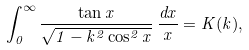<formula> <loc_0><loc_0><loc_500><loc_500>\int _ { 0 } ^ { \infty } \frac { \tan x } { \sqrt { 1 - k ^ { 2 } \cos ^ { 2 } x } } \, \frac { d x } { x } = K ( k ) ,</formula> 